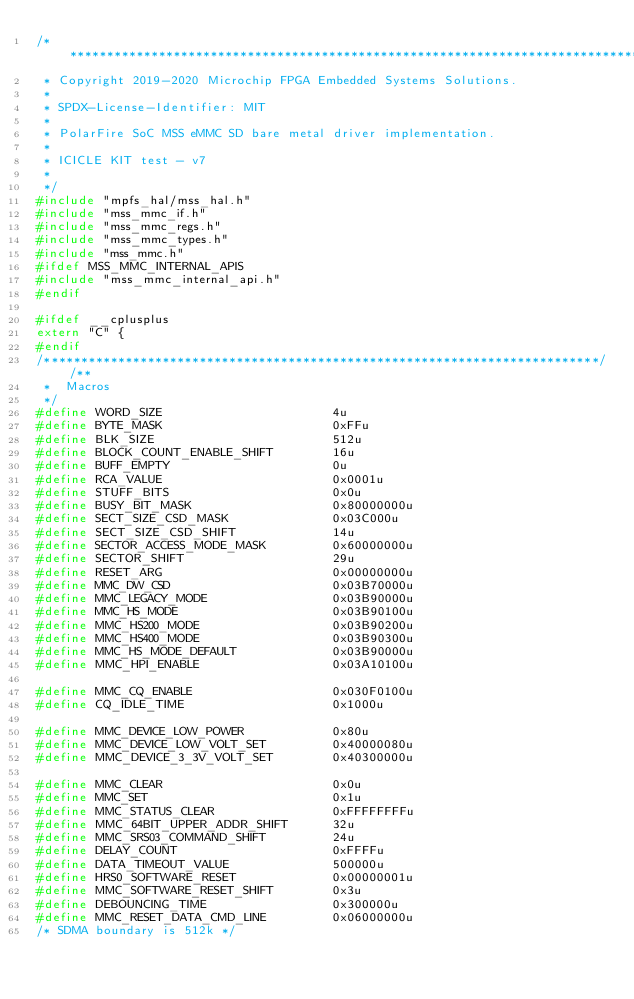<code> <loc_0><loc_0><loc_500><loc_500><_C_>/*******************************************************************************
 * Copyright 2019-2020 Microchip FPGA Embedded Systems Solutions.
 *
 * SPDX-License-Identifier: MIT
 *
 * PolarFire SoC MSS eMMC SD bare metal driver implementation.
 *
 * ICICLE KIT test - v7
 *
 */
#include "mpfs_hal/mss_hal.h"
#include "mss_mmc_if.h"
#include "mss_mmc_regs.h"
#include "mss_mmc_types.h"
#include "mss_mmc.h"
#ifdef MSS_MMC_INTERNAL_APIS
#include "mss_mmc_internal_api.h"
#endif

#ifdef __cplusplus
extern "C" {
#endif
/***************************************************************************//**
 *  Macros
 */
#define WORD_SIZE                       4u
#define BYTE_MASK                       0xFFu
#define BLK_SIZE                        512u
#define BLOCK_COUNT_ENABLE_SHIFT        16u
#define BUFF_EMPTY                      0u
#define RCA_VALUE                       0x0001u
#define STUFF_BITS                      0x0u
#define BUSY_BIT_MASK                   0x80000000u
#define SECT_SIZE_CSD_MASK              0x03C000u
#define SECT_SIZE_CSD_SHIFT             14u
#define SECTOR_ACCESS_MODE_MASK         0x60000000u
#define SECTOR_SHIFT                    29u
#define RESET_ARG                       0x00000000u
#define MMC_DW_CSD                      0x03B70000u
#define MMC_LEGACY_MODE                 0x03B90000u
#define MMC_HS_MODE                     0x03B90100u
#define MMC_HS200_MODE                  0x03B90200u
#define MMC_HS400_MODE                  0x03B90300u
#define MMC_HS_MODE_DEFAULT             0x03B90000u
#define MMC_HPI_ENABLE                  0x03A10100u

#define MMC_CQ_ENABLE                   0x030F0100u
#define CQ_IDLE_TIME                    0x1000u

#define MMC_DEVICE_LOW_POWER            0x80u
#define MMC_DEVICE_LOW_VOLT_SET         0x40000080u
#define MMC_DEVICE_3_3V_VOLT_SET        0x40300000u

#define MMC_CLEAR                       0x0u
#define MMC_SET                         0x1u
#define MMC_STATUS_CLEAR                0xFFFFFFFFu
#define MMC_64BIT_UPPER_ADDR_SHIFT      32u
#define MMC_SRS03_COMMAND_SHIFT         24u
#define DELAY_COUNT                     0xFFFFu
#define DATA_TIMEOUT_VALUE              500000u
#define HRS0_SOFTWARE_RESET             0x00000001u
#define MMC_SOFTWARE_RESET_SHIFT        0x3u
#define DEBOUNCING_TIME                 0x300000u
#define MMC_RESET_DATA_CMD_LINE         0x06000000u
/* SDMA boundary is 512k */</code> 